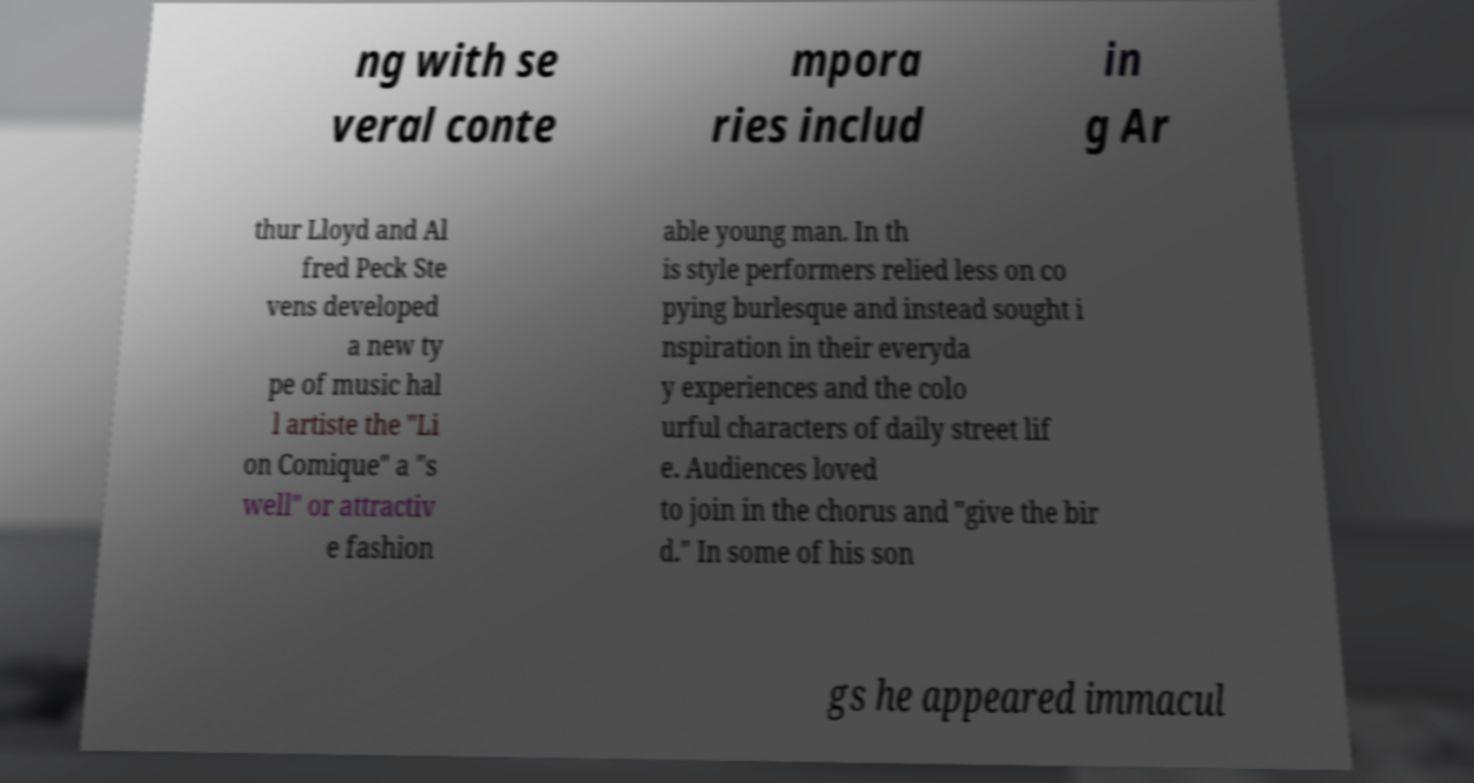Could you extract and type out the text from this image? ng with se veral conte mpora ries includ in g Ar thur Lloyd and Al fred Peck Ste vens developed a new ty pe of music hal l artiste the "Li on Comique" a "s well" or attractiv e fashion able young man. In th is style performers relied less on co pying burlesque and instead sought i nspiration in their everyda y experiences and the colo urful characters of daily street lif e. Audiences loved to join in the chorus and "give the bir d." In some of his son gs he appeared immacul 